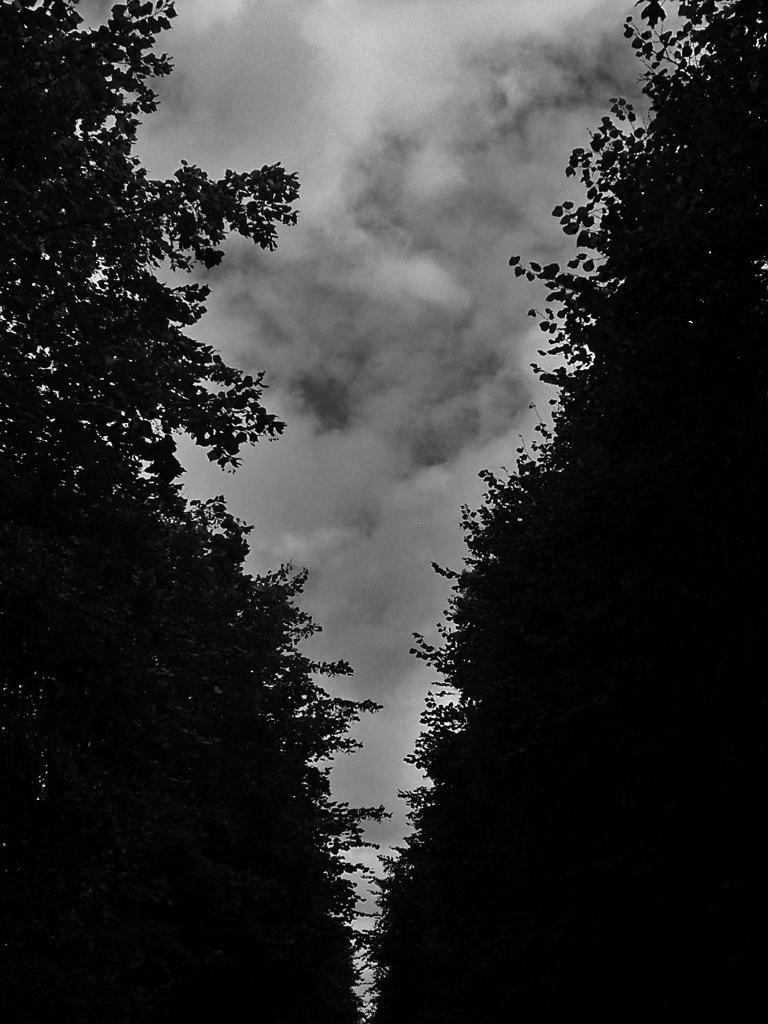Could you give a brief overview of what you see in this image? In this image we can see group of trees and in the background we can see cloudy sky. 